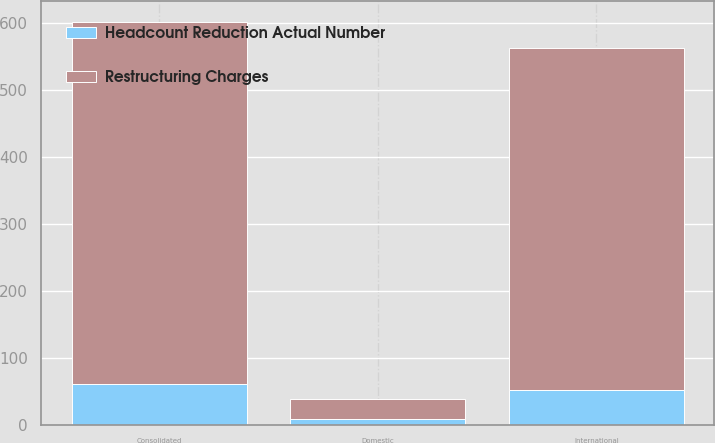Convert chart to OTSL. <chart><loc_0><loc_0><loc_500><loc_500><stacked_bar_chart><ecel><fcel>Consolidated<fcel>Domestic<fcel>International<nl><fcel>Headcount Reduction Actual Number<fcel>61.2<fcel>9<fcel>52.2<nl><fcel>Restructuring Charges<fcel>541<fcel>30<fcel>511<nl></chart> 